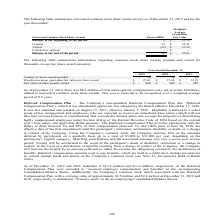According to Sykes Enterprises Incorporated's financial document, What was the Number of share awards granted in 2019? According to the financial document, 34 (in thousands). The relevant text states: "Number of share awards granted 34 34 24..." Also, What was the Fair value of share awards vested in 2017? According to the financial document, $850 (in thousands). The relevant text states: "Fair value of share awards vested $ 840 $ 880 $ 850..." Also, In which years was the Number of share awards granted calculated? The document contains multiple relevant values: 2019, 2018, 2017. From the document: "2019 2018 2017 2019 2018 2017 2019 2018 2017..." Additionally, In which year was the Weighted average grant-date fair value per share award the largest? According to the financial document, 2017. The relevant text states: "2019 2018 2017..." Also, can you calculate: What was the change in Fair value of share awards vested in 2019 from 2018? Based on the calculation: 840-880, the result is -40 (in thousands). This is based on the information: "Fair value of share awards vested $ 840 $ 880 $ 850 Fair value of share awards vested $ 840 $ 880 $ 850..." The key data points involved are: 840, 880. Also, can you calculate: What was the percentage change in Fair value of share awards vested in 2019 from 2018? To answer this question, I need to perform calculations using the financial data. The calculation is: (840-880)/880, which equals -4.55 (percentage). This is based on the information: "Fair value of share awards vested $ 840 $ 880 $ 850 Fair value of share awards vested $ 840 $ 880 $ 850..." The key data points involved are: 840, 880. 